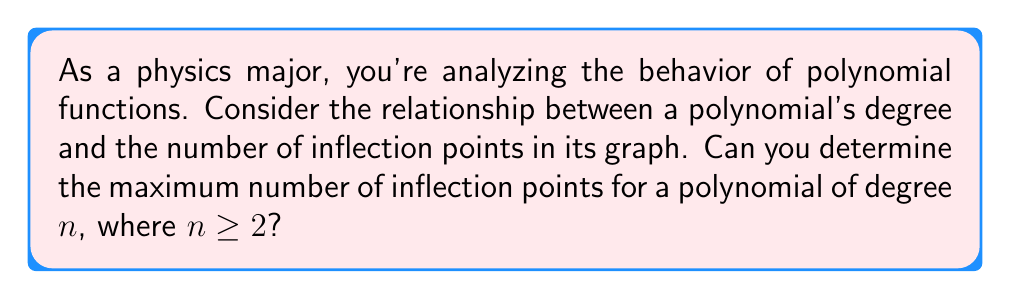What is the answer to this math problem? Let's approach this step-by-step:

1) First, recall that an inflection point occurs where the concavity of a function changes. This happens when the second derivative changes sign.

2) For a polynomial $f(x)$ of degree $n$, its first derivative $f'(x)$ will be a polynomial of degree $n-1$.

3) The second derivative $f''(x)$ will be a polynomial of degree $n-2$.

4) Inflection points occur where $f''(x) = 0$ and the sign of $f''(x)$ changes around this point.

5) A polynomial of degree $n-2$ can have at most $n-2$ real roots.

6) However, not all roots of $f''(x)$ necessarily correspond to inflection points. We need the function to actually change concavity at these points.

7) The maximum number of inflection points will occur when all roots of $f''(x)$ correspond to changes in concavity.

8) Therefore, the maximum number of inflection points for a polynomial of degree $n$ is $n-2$.

9) Note that this is valid for $n \geq 2$, as polynomials of degree 0 or 1 (constant and linear functions) have no inflection points.
Answer: $n-2$ 